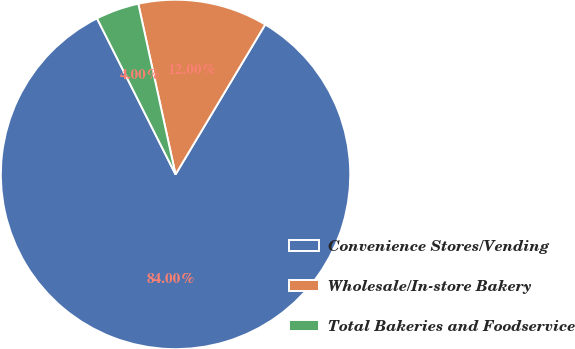Convert chart. <chart><loc_0><loc_0><loc_500><loc_500><pie_chart><fcel>Convenience Stores/Vending<fcel>Wholesale/In-store Bakery<fcel>Total Bakeries and Foodservice<nl><fcel>84.0%<fcel>12.0%<fcel>4.0%<nl></chart> 